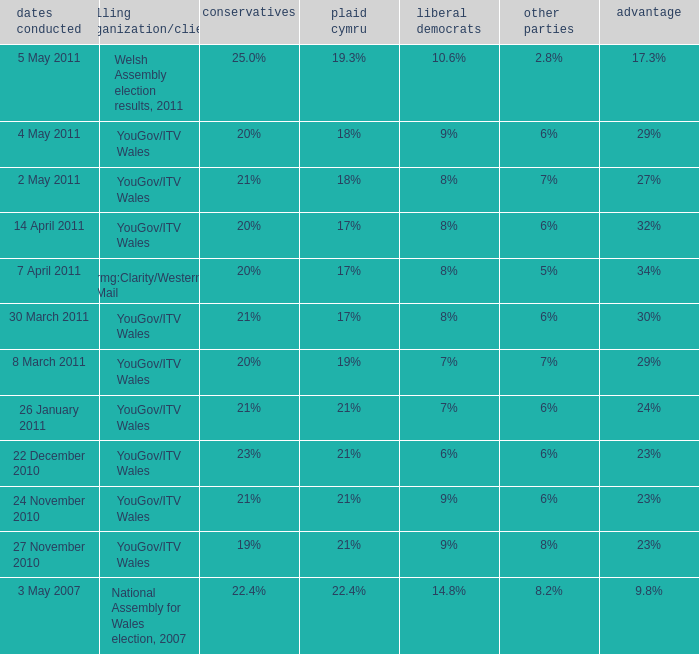I want the plaid cymru for 4 may 2011 18%. 